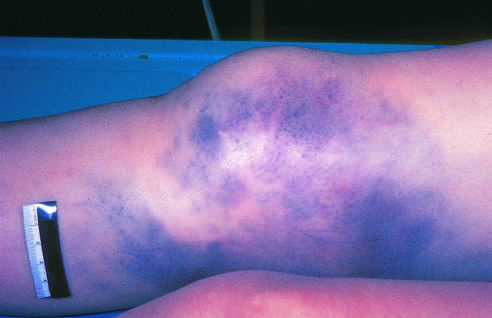s the zygosity plot intact?
Answer the question using a single word or phrase. No 